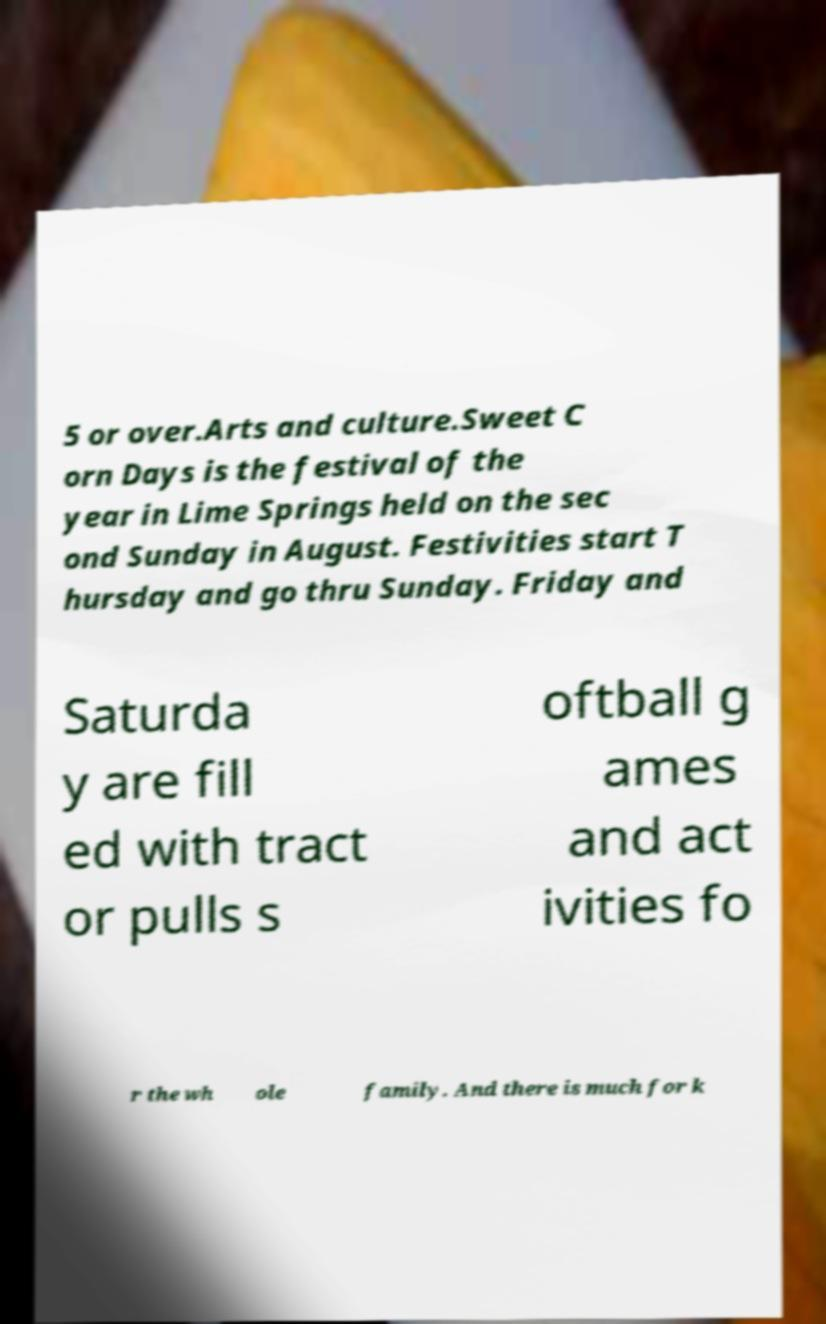Please read and relay the text visible in this image. What does it say? 5 or over.Arts and culture.Sweet C orn Days is the festival of the year in Lime Springs held on the sec ond Sunday in August. Festivities start T hursday and go thru Sunday. Friday and Saturda y are fill ed with tract or pulls s oftball g ames and act ivities fo r the wh ole family. And there is much for k 